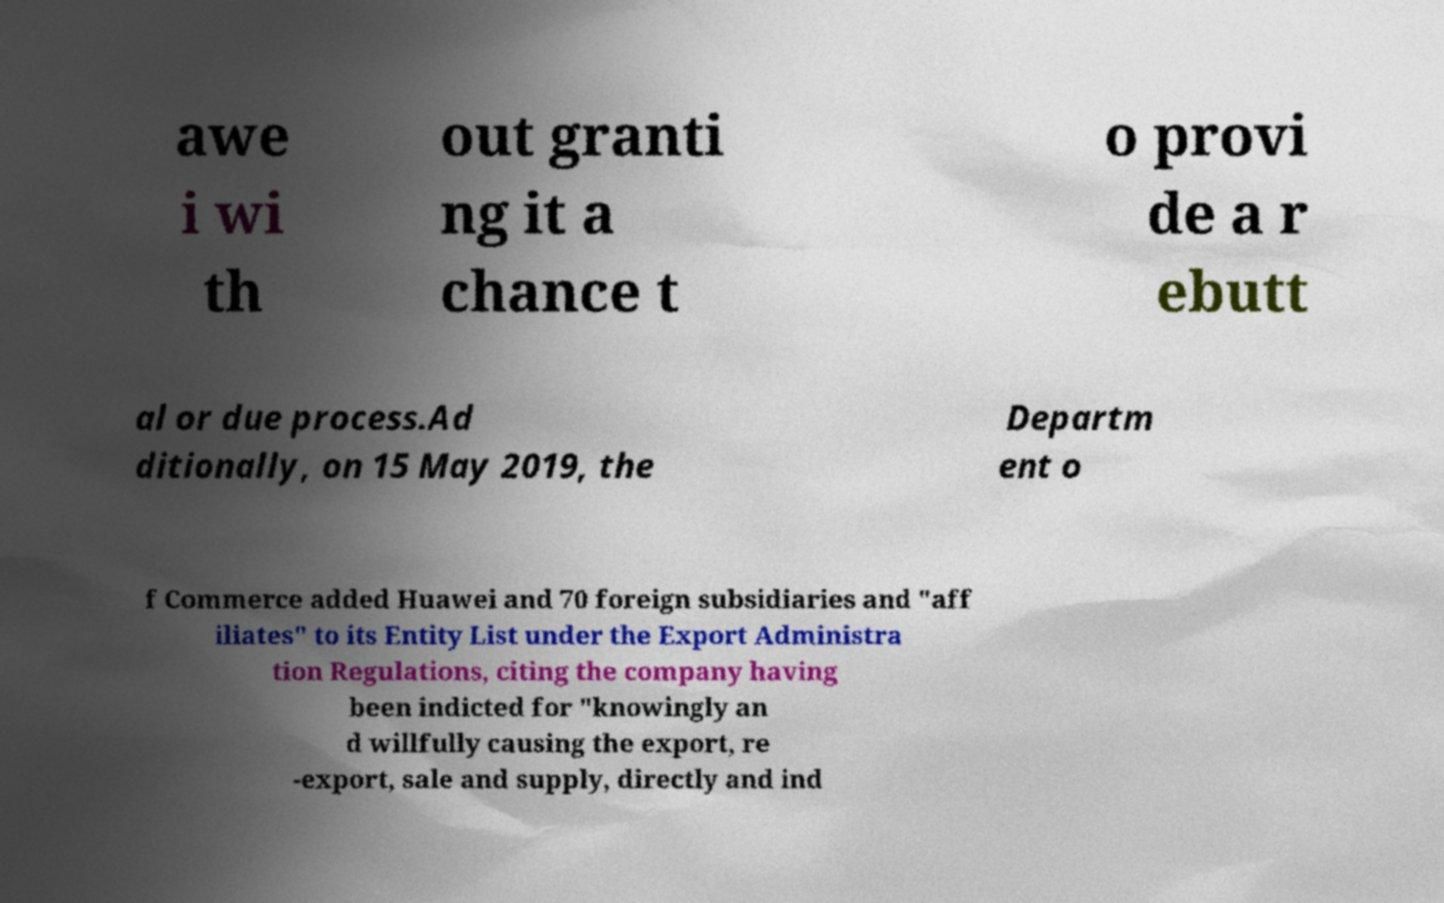Can you accurately transcribe the text from the provided image for me? awe i wi th out granti ng it a chance t o provi de a r ebutt al or due process.Ad ditionally, on 15 May 2019, the Departm ent o f Commerce added Huawei and 70 foreign subsidiaries and "aff iliates" to its Entity List under the Export Administra tion Regulations, citing the company having been indicted for "knowingly an d willfully causing the export, re -export, sale and supply, directly and ind 